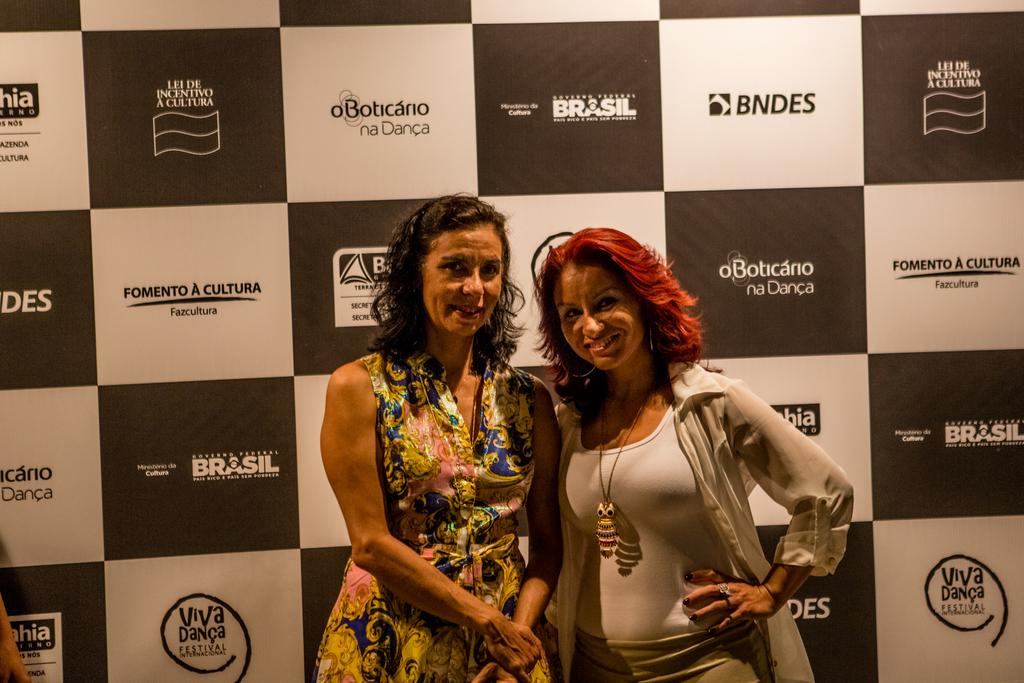How many women are present in the image? There are two women standing in the image. Can you describe the appearance of one of the women? One of the women has red hair and is wearing white clothes. What can be seen in the background of the image? There is a sign board visible in the background of the image. What type of bean is being used to create shade for the women in the image? There are no beans present in the image, nor is there any indication that the women are seeking shade. 